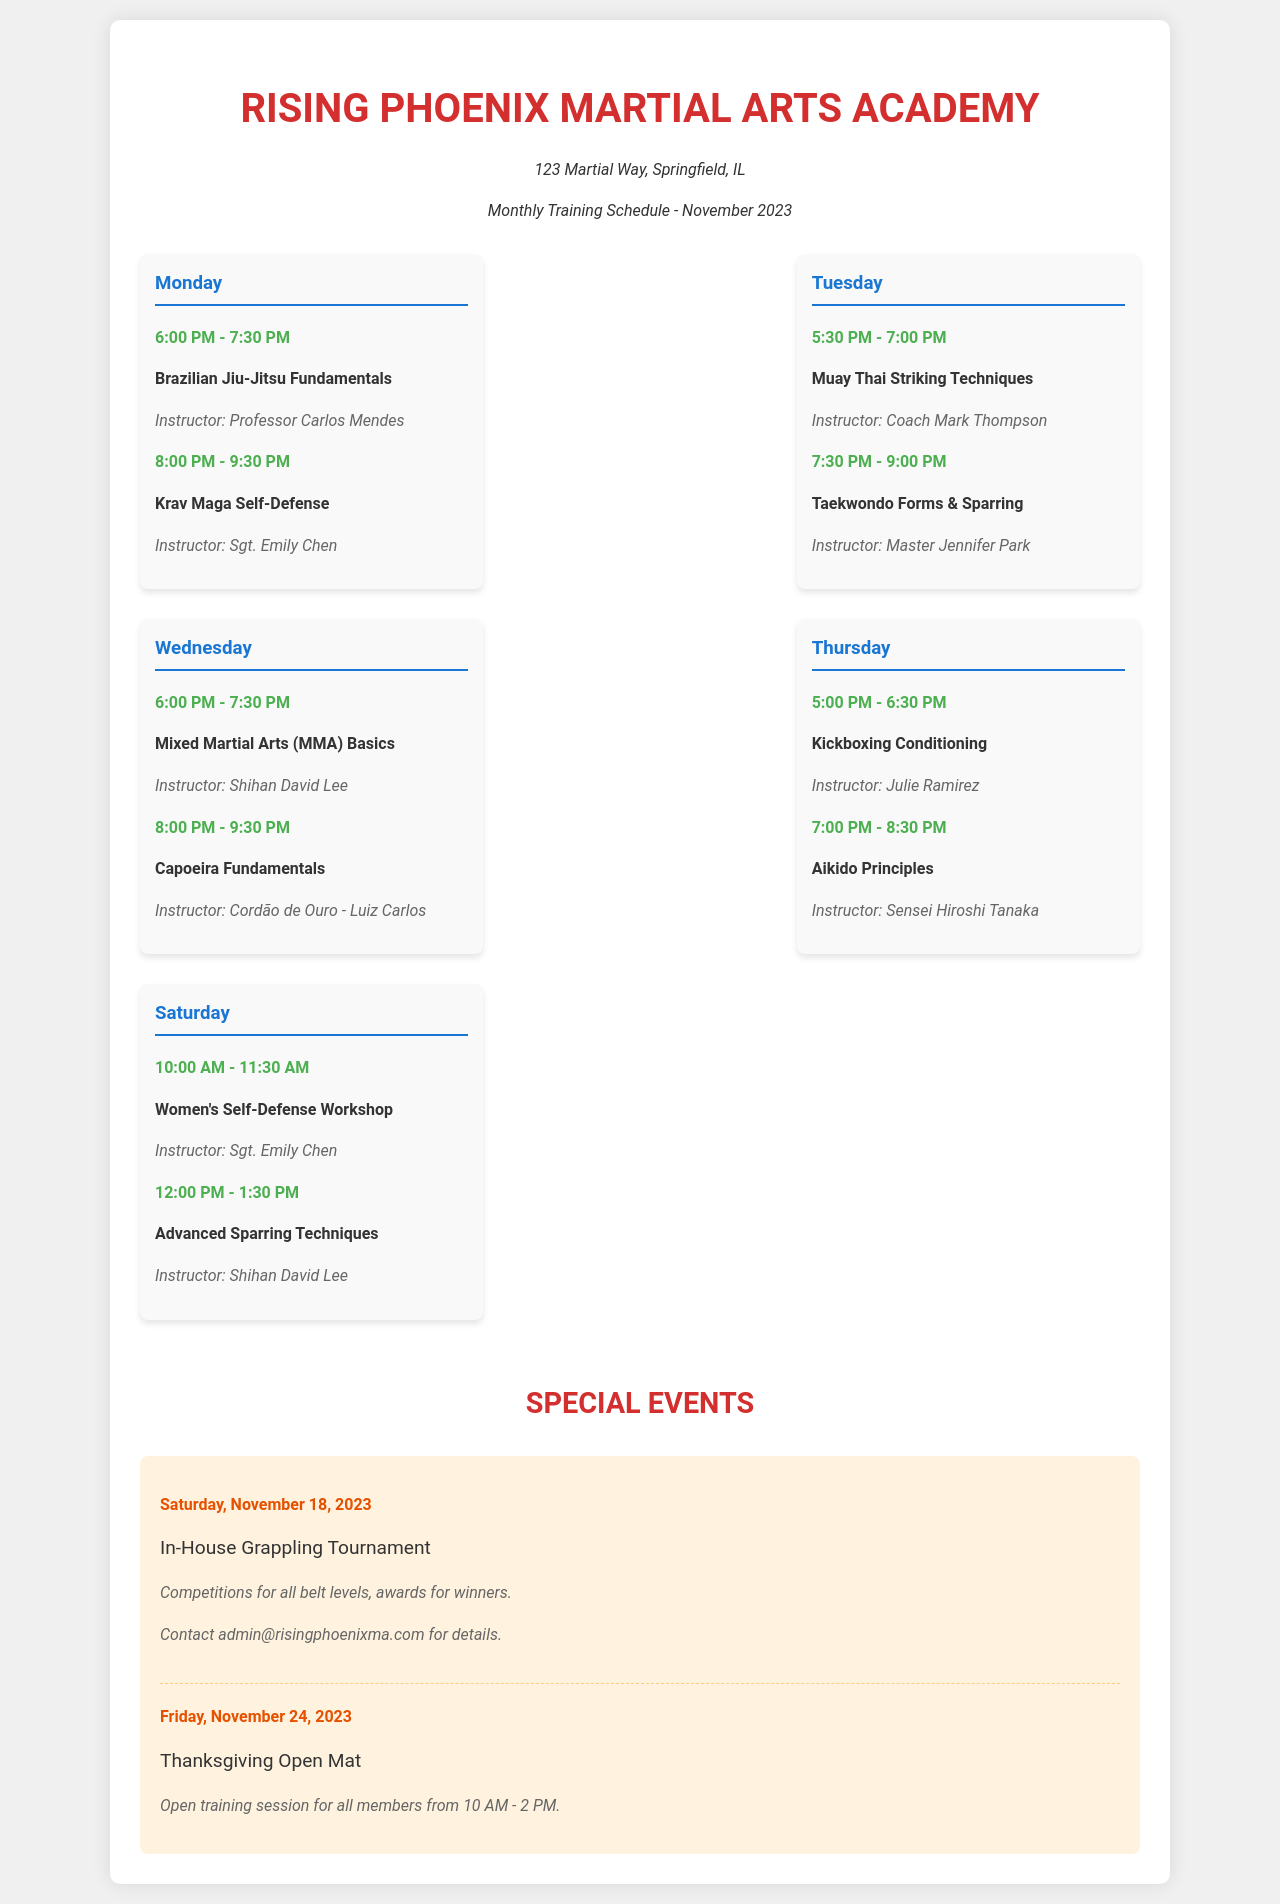What class is taught by Professor Carlos Mendes? Professor Carlos Mendes teaches the Brazilian Jiu-Jitsu Fundamentals class on Mondays from 6:00 PM to 7:30 PM.
Answer: Brazilian Jiu-Jitsu Fundamentals Who instructs the Saturday Women's Self-Defense Workshop? The Saturday Women's Self-Defense Workshop is instructed by Sgt. Emily Chen at 10:00 AM.
Answer: Sgt. Emily Chen What time does the Krav Maga Self-Defense class begin? The Krav Maga Self-Defense class is held on Mondays at 8:00 PM.
Answer: 8:00 PM When is the In-House Grappling Tournament scheduled? The In-House Grappling Tournament is scheduled for Saturday, November 18, 2023.
Answer: November 18, 2023 How long is the Thanksgiving Open Mat session? The Thanksgiving Open Mat session runs from 10 AM to 2 PM, which is 4 hours.
Answer: 4 hours Which martial art is taught by Sensei Hiroshi Tanaka? Sensei Hiroshi Tanaka teaches Aikido Principles on Thursdays from 7:00 PM to 8:30 PM.
Answer: Aikido What is the duration of the Advanced Sparring Techniques class? The Advanced Sparring Techniques class is from 12:00 PM to 1:30 PM on Saturday, lasting 1 hour and 30 minutes.
Answer: 1 hour and 30 minutes 